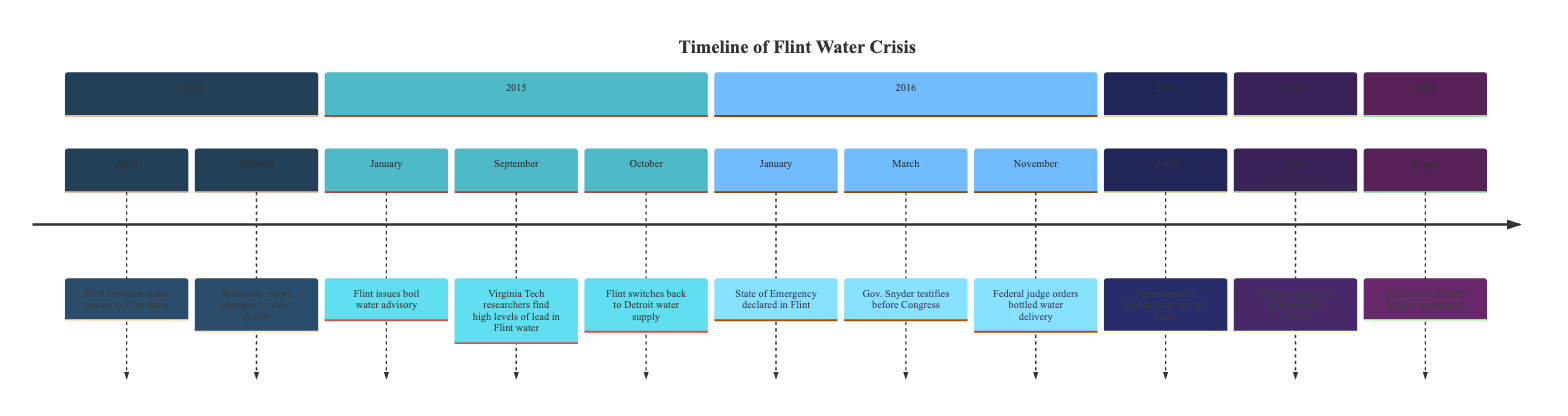What event took place in April 2014? The diagram shows that in April 2014, Flint switched its water source to Flint River. This is a direct reference in the timeline for that year.
Answer: Flint switched water source to Flint River How many key events are listed for 2015? In the diagram, there are three key events listed for 2015: the boil water advisory in January, the findings by Virginia Tech in September, and the switch back to Detroit water in October. Counting these gives a total of three events.
Answer: 3 What was declared in January 2016? According to the timeline, the State of Emergency was declared in Flint in January 2016. This information is explicitly stated in the timeline section for that year.
Answer: State of Emergency What significant action took place in March 2017? The diagram indicates that in March 2017, agreements were made to replace lead service lines. This represents a key milestone after earlier crises related to water contamination.
Answer: Agreements to replace lead service lines Which event occurred first, the boil water advisory or Virginia Tech's findings? The timeline shows that the boil water advisory was issued in January 2015, and Virginia Tech's findings were reported in September 2015. Since January comes before September, the boil water advisory occurred first.
Answer: Boil water advisory How many years are represented in the timeline from 2014 to 2020? The timeline includes six years: 2014, 2015, 2016, 2017, 2019, and 2020. Counting these years yields a total of six.
Answer: 6 What was the total amount of the settlement announced in August 2020? The diagram notes a settlement of $600 million announced in August 2020. This amount is directly mentioned in the section for that year.
Answer: $600 million What major event happened in November 2016? According to the timeline, in November 2016, a federal judge ordered the delivery of bottled water. This is a clear event stated in the diagram for that year.
Answer: Federal judge orders bottled water delivery 